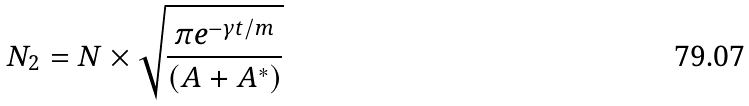Convert formula to latex. <formula><loc_0><loc_0><loc_500><loc_500>N _ { 2 } = N \times \sqrt { \frac { \pi e ^ { - \gamma t / m } } { ( A + A ^ { * } ) } }</formula> 